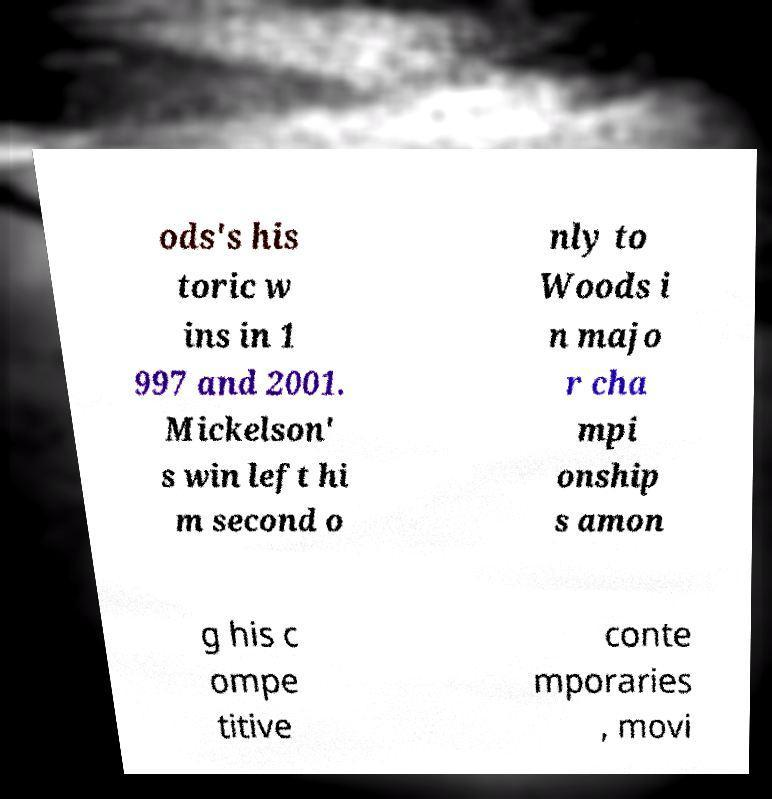There's text embedded in this image that I need extracted. Can you transcribe it verbatim? ods's his toric w ins in 1 997 and 2001. Mickelson' s win left hi m second o nly to Woods i n majo r cha mpi onship s amon g his c ompe titive conte mporaries , movi 